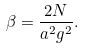Convert formula to latex. <formula><loc_0><loc_0><loc_500><loc_500>\beta = \frac { 2 N } { a ^ { 2 } g ^ { 2 } } .</formula> 